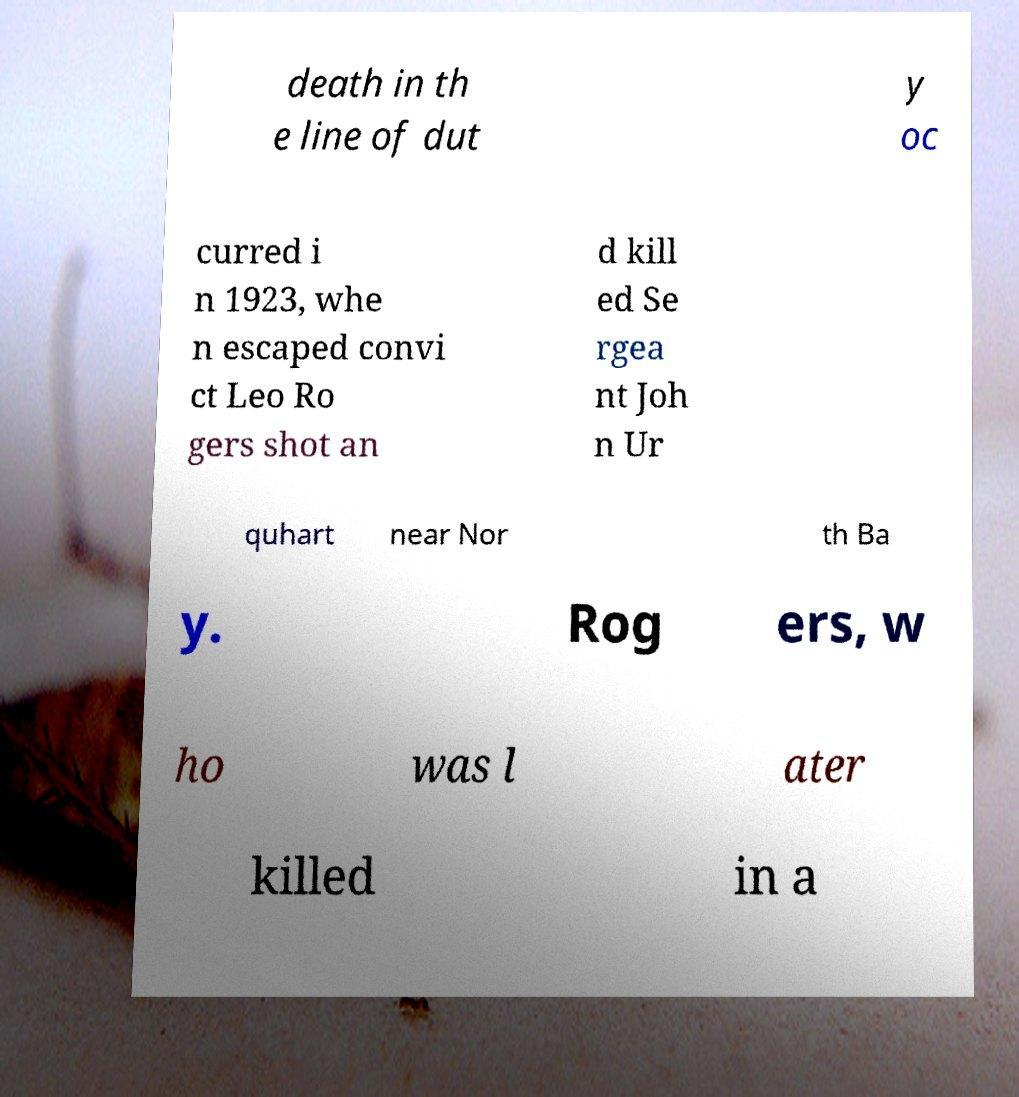Could you assist in decoding the text presented in this image and type it out clearly? death in th e line of dut y oc curred i n 1923, whe n escaped convi ct Leo Ro gers shot an d kill ed Se rgea nt Joh n Ur quhart near Nor th Ba y. Rog ers, w ho was l ater killed in a 